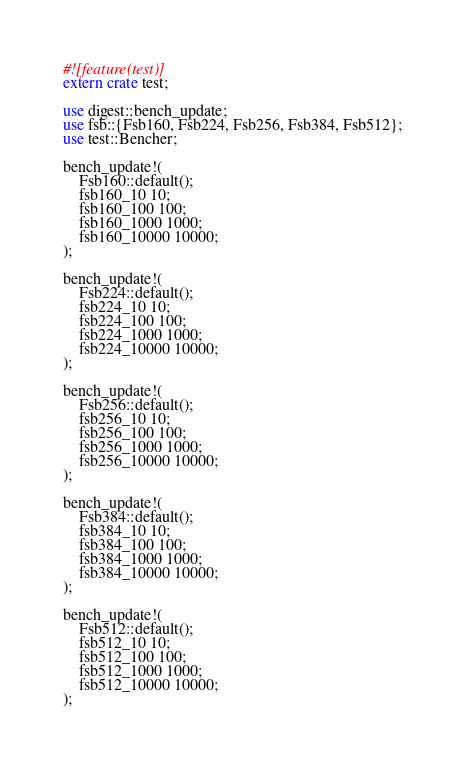<code> <loc_0><loc_0><loc_500><loc_500><_Rust_>#![feature(test)]
extern crate test;

use digest::bench_update;
use fsb::{Fsb160, Fsb224, Fsb256, Fsb384, Fsb512};
use test::Bencher;

bench_update!(
    Fsb160::default();
    fsb160_10 10;
    fsb160_100 100;
    fsb160_1000 1000;
    fsb160_10000 10000;
);

bench_update!(
    Fsb224::default();
    fsb224_10 10;
    fsb224_100 100;
    fsb224_1000 1000;
    fsb224_10000 10000;
);

bench_update!(
    Fsb256::default();
    fsb256_10 10;
    fsb256_100 100;
    fsb256_1000 1000;
    fsb256_10000 10000;
);

bench_update!(
    Fsb384::default();
    fsb384_10 10;
    fsb384_100 100;
    fsb384_1000 1000;
    fsb384_10000 10000;
);

bench_update!(
    Fsb512::default();
    fsb512_10 10;
    fsb512_100 100;
    fsb512_1000 1000;
    fsb512_10000 10000;
);
</code> 